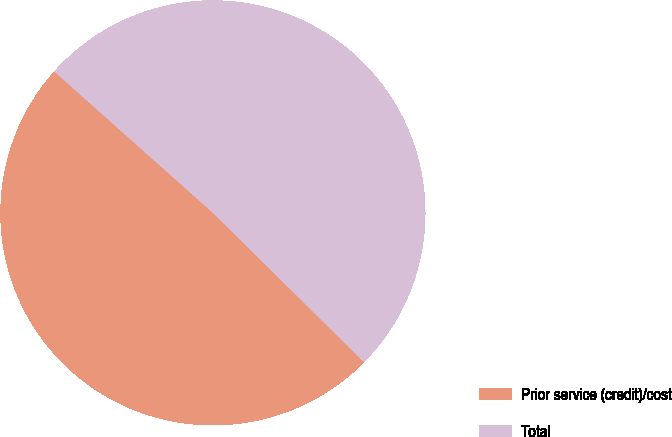Convert chart. <chart><loc_0><loc_0><loc_500><loc_500><pie_chart><fcel>Prior service (credit)/cost<fcel>Total<nl><fcel>49.18%<fcel>50.82%<nl></chart> 